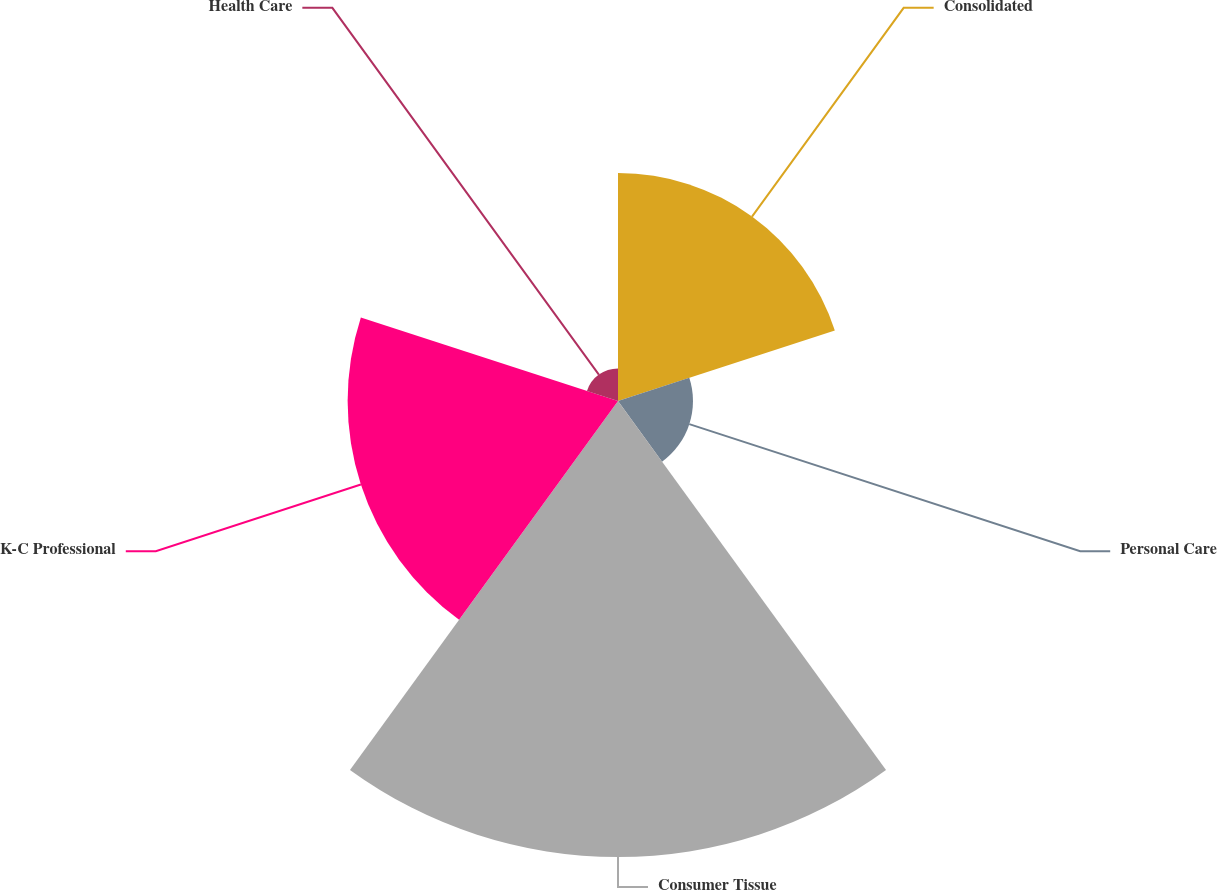<chart> <loc_0><loc_0><loc_500><loc_500><pie_chart><fcel>Consolidated<fcel>Personal Care<fcel>Consumer Tissue<fcel>K-C Professional<fcel>Health Care<nl><fcel>21.47%<fcel>7.06%<fcel>42.94%<fcel>25.46%<fcel>3.07%<nl></chart> 